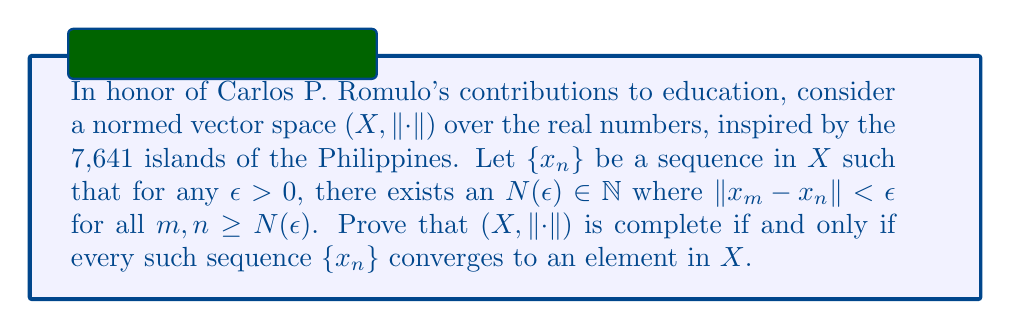Give your solution to this math problem. Let's approach this proof step-by-step:

1) First, we'll prove that if $(X, \|\cdot\|)$ is complete, then every Cauchy sequence converges in $X$.

   Let $\{x_n\}$ be a Cauchy sequence in $X$. By definition of completeness, we need to show that $\{x_n\}$ converges to some $x \in X$.

   Since $\{x_n\}$ is Cauchy, for any $\epsilon > 0$, there exists $N(\epsilon) \in \mathbb{N}$ such that:

   $$\|x_m - x_n\| < \epsilon \quad \text{for all } m, n \geq N(\epsilon)$$

   By the completeness of $X$, there exists $x \in X$ such that $x_n \to x$ as $n \to \infty$.

2) Now, we'll prove the converse: if every Cauchy sequence in $X$ converges to an element in $X$, then $X$ is complete.

   Let $\{x_n\}$ be any Cauchy sequence in $X$. We need to show that $\{x_n\}$ converges in $X$.

   By the hypothesis, since $\{x_n\}$ is Cauchy, it converges to some $x \in X$.

   This means that for any $\epsilon > 0$, there exists $N(\epsilon) \in \mathbb{N}$ such that:

   $$\|x_n - x\| < \epsilon \quad \text{for all } n \geq N(\epsilon)$$

   Therefore, $X$ is complete.

3) Combining (1) and (2), we have proven that $(X, \|\cdot\|)$ is complete if and only if every Cauchy sequence in $X$ converges to an element in $X$.

This proof demonstrates the fundamental relationship between completeness and the convergence of Cauchy sequences in normed vector spaces, a concept that Mr. Romulo would appreciate for its elegance and importance in mathematical analysis.
Answer: $(X, \|\cdot\|)$ is complete if and only if every Cauchy sequence in $X$ converges to an element in $X$. 